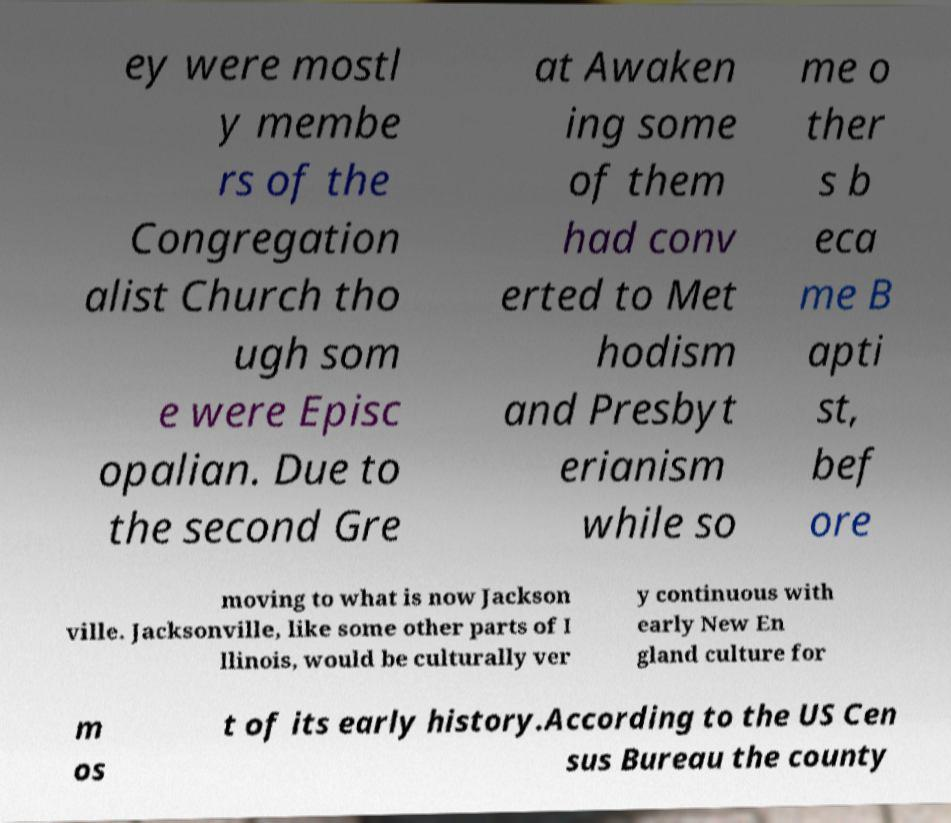What messages or text are displayed in this image? I need them in a readable, typed format. ey were mostl y membe rs of the Congregation alist Church tho ugh som e were Episc opalian. Due to the second Gre at Awaken ing some of them had conv erted to Met hodism and Presbyt erianism while so me o ther s b eca me B apti st, bef ore moving to what is now Jackson ville. Jacksonville, like some other parts of I llinois, would be culturally ver y continuous with early New En gland culture for m os t of its early history.According to the US Cen sus Bureau the county 